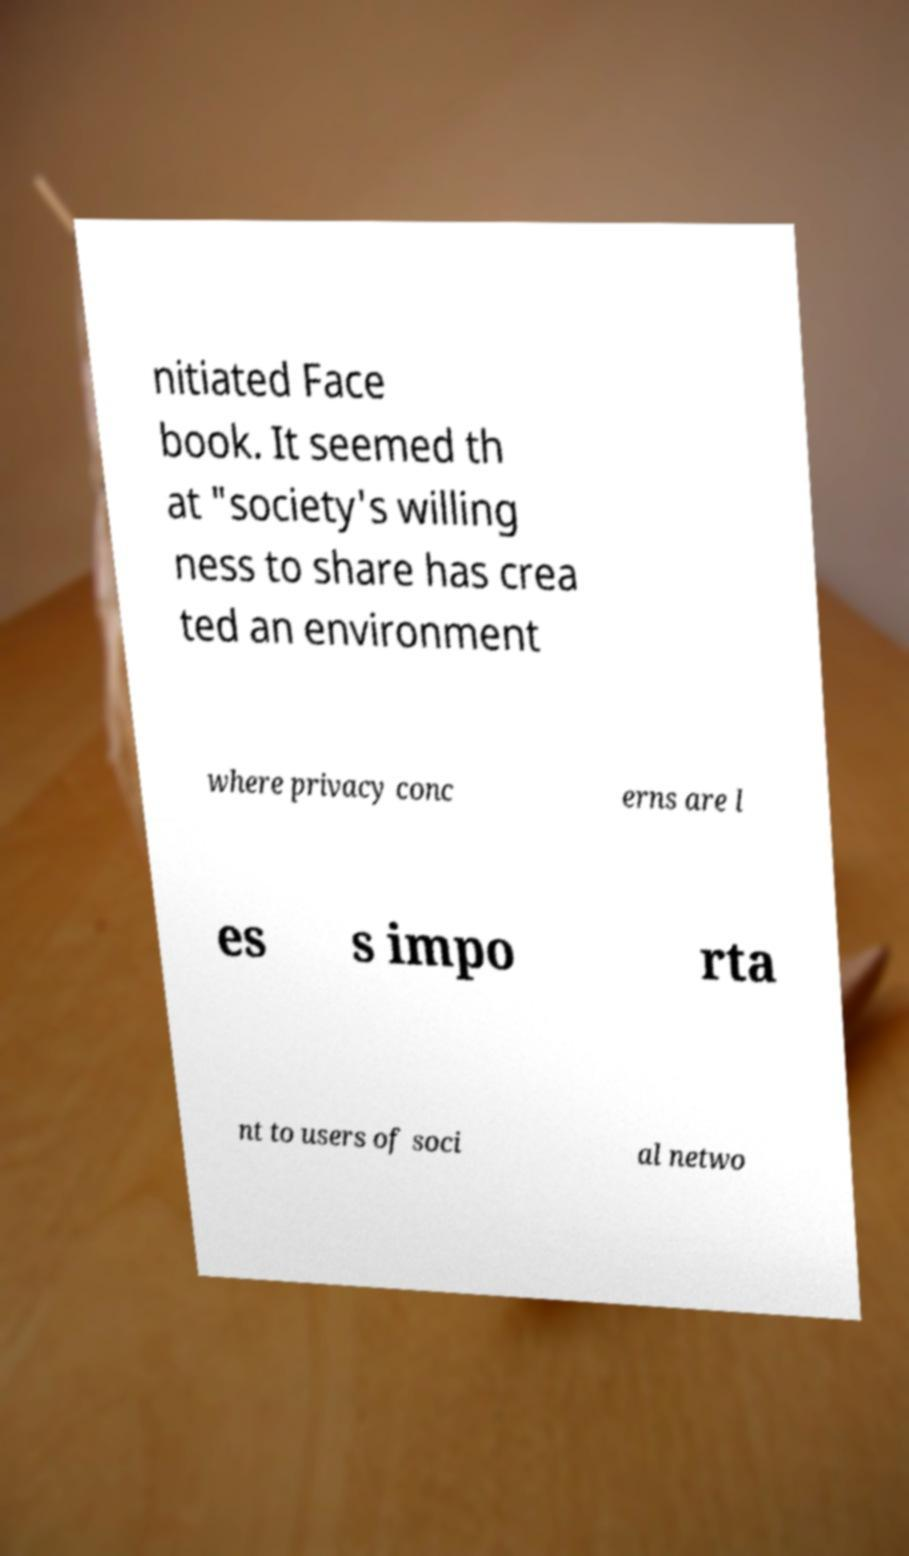I need the written content from this picture converted into text. Can you do that? nitiated Face book. It seemed th at "society's willing ness to share has crea ted an environment where privacy conc erns are l es s impo rta nt to users of soci al netwo 